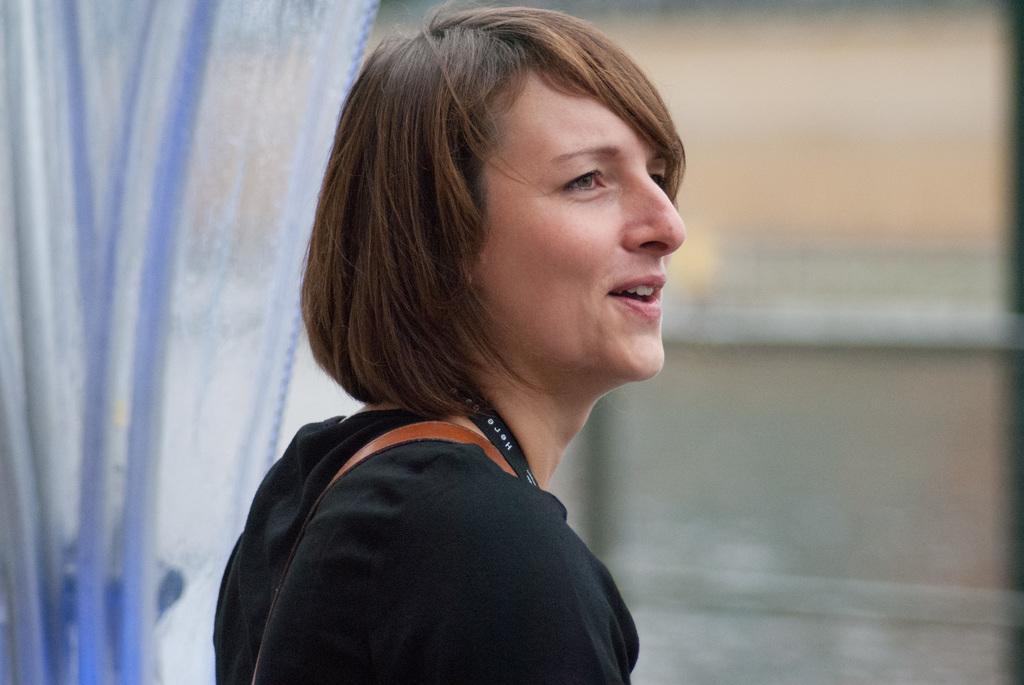In one or two sentences, can you explain what this image depicts? This is a picture of a woman smiling , and in the background there is a curtain and window. 